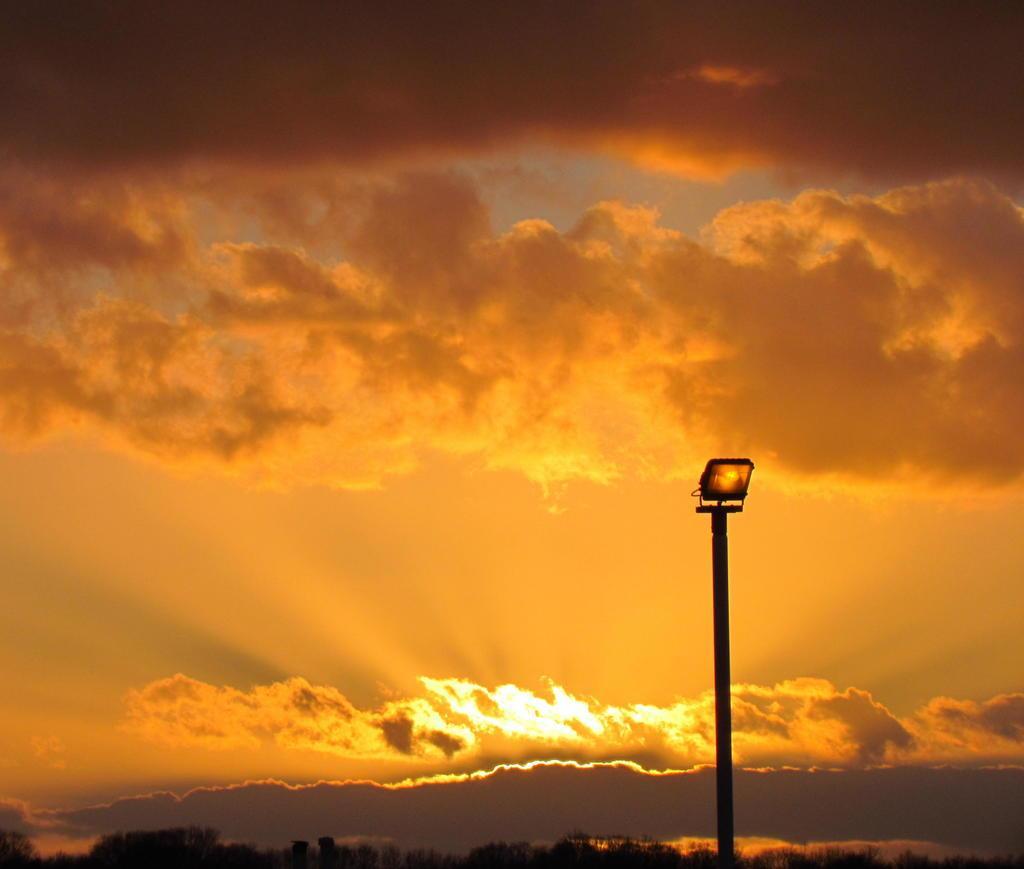Could you give a brief overview of what you see in this image? In this image there is a street light, trees and the sky. 